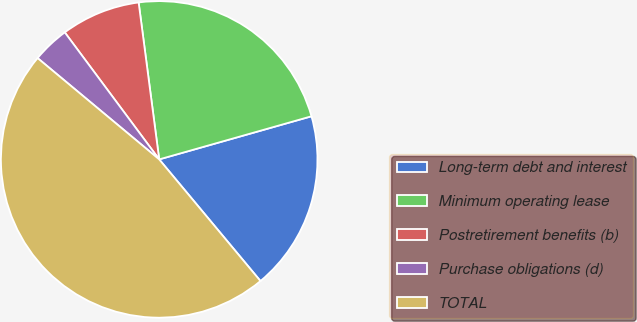Convert chart. <chart><loc_0><loc_0><loc_500><loc_500><pie_chart><fcel>Long-term debt and interest<fcel>Minimum operating lease<fcel>Postretirement benefits (b)<fcel>Purchase obligations (d)<fcel>TOTAL<nl><fcel>18.34%<fcel>22.68%<fcel>8.1%<fcel>3.77%<fcel>47.1%<nl></chart> 